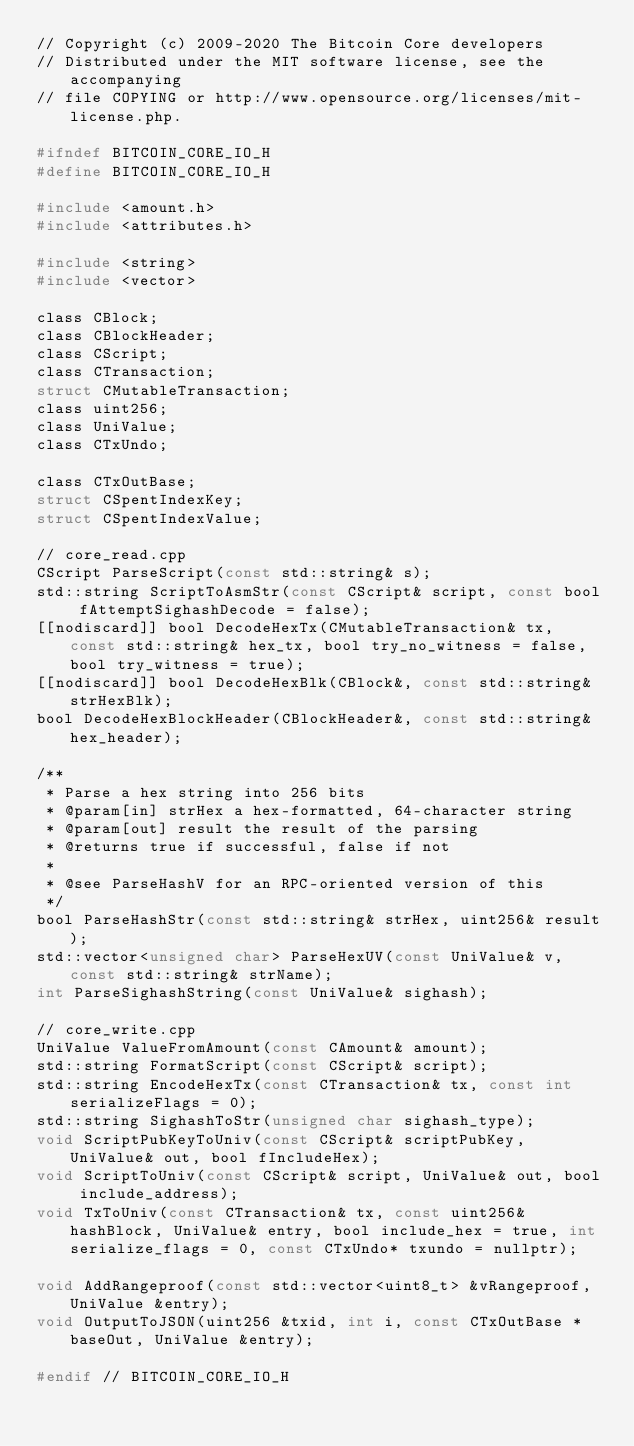Convert code to text. <code><loc_0><loc_0><loc_500><loc_500><_C_>// Copyright (c) 2009-2020 The Bitcoin Core developers
// Distributed under the MIT software license, see the accompanying
// file COPYING or http://www.opensource.org/licenses/mit-license.php.

#ifndef BITCOIN_CORE_IO_H
#define BITCOIN_CORE_IO_H

#include <amount.h>
#include <attributes.h>

#include <string>
#include <vector>

class CBlock;
class CBlockHeader;
class CScript;
class CTransaction;
struct CMutableTransaction;
class uint256;
class UniValue;
class CTxUndo;

class CTxOutBase;
struct CSpentIndexKey;
struct CSpentIndexValue;

// core_read.cpp
CScript ParseScript(const std::string& s);
std::string ScriptToAsmStr(const CScript& script, const bool fAttemptSighashDecode = false);
[[nodiscard]] bool DecodeHexTx(CMutableTransaction& tx, const std::string& hex_tx, bool try_no_witness = false, bool try_witness = true);
[[nodiscard]] bool DecodeHexBlk(CBlock&, const std::string& strHexBlk);
bool DecodeHexBlockHeader(CBlockHeader&, const std::string& hex_header);

/**
 * Parse a hex string into 256 bits
 * @param[in] strHex a hex-formatted, 64-character string
 * @param[out] result the result of the parsing
 * @returns true if successful, false if not
 *
 * @see ParseHashV for an RPC-oriented version of this
 */
bool ParseHashStr(const std::string& strHex, uint256& result);
std::vector<unsigned char> ParseHexUV(const UniValue& v, const std::string& strName);
int ParseSighashString(const UniValue& sighash);

// core_write.cpp
UniValue ValueFromAmount(const CAmount& amount);
std::string FormatScript(const CScript& script);
std::string EncodeHexTx(const CTransaction& tx, const int serializeFlags = 0);
std::string SighashToStr(unsigned char sighash_type);
void ScriptPubKeyToUniv(const CScript& scriptPubKey, UniValue& out, bool fIncludeHex);
void ScriptToUniv(const CScript& script, UniValue& out, bool include_address);
void TxToUniv(const CTransaction& tx, const uint256& hashBlock, UniValue& entry, bool include_hex = true, int serialize_flags = 0, const CTxUndo* txundo = nullptr);

void AddRangeproof(const std::vector<uint8_t> &vRangeproof, UniValue &entry);
void OutputToJSON(uint256 &txid, int i, const CTxOutBase *baseOut, UniValue &entry);

#endif // BITCOIN_CORE_IO_H
</code> 